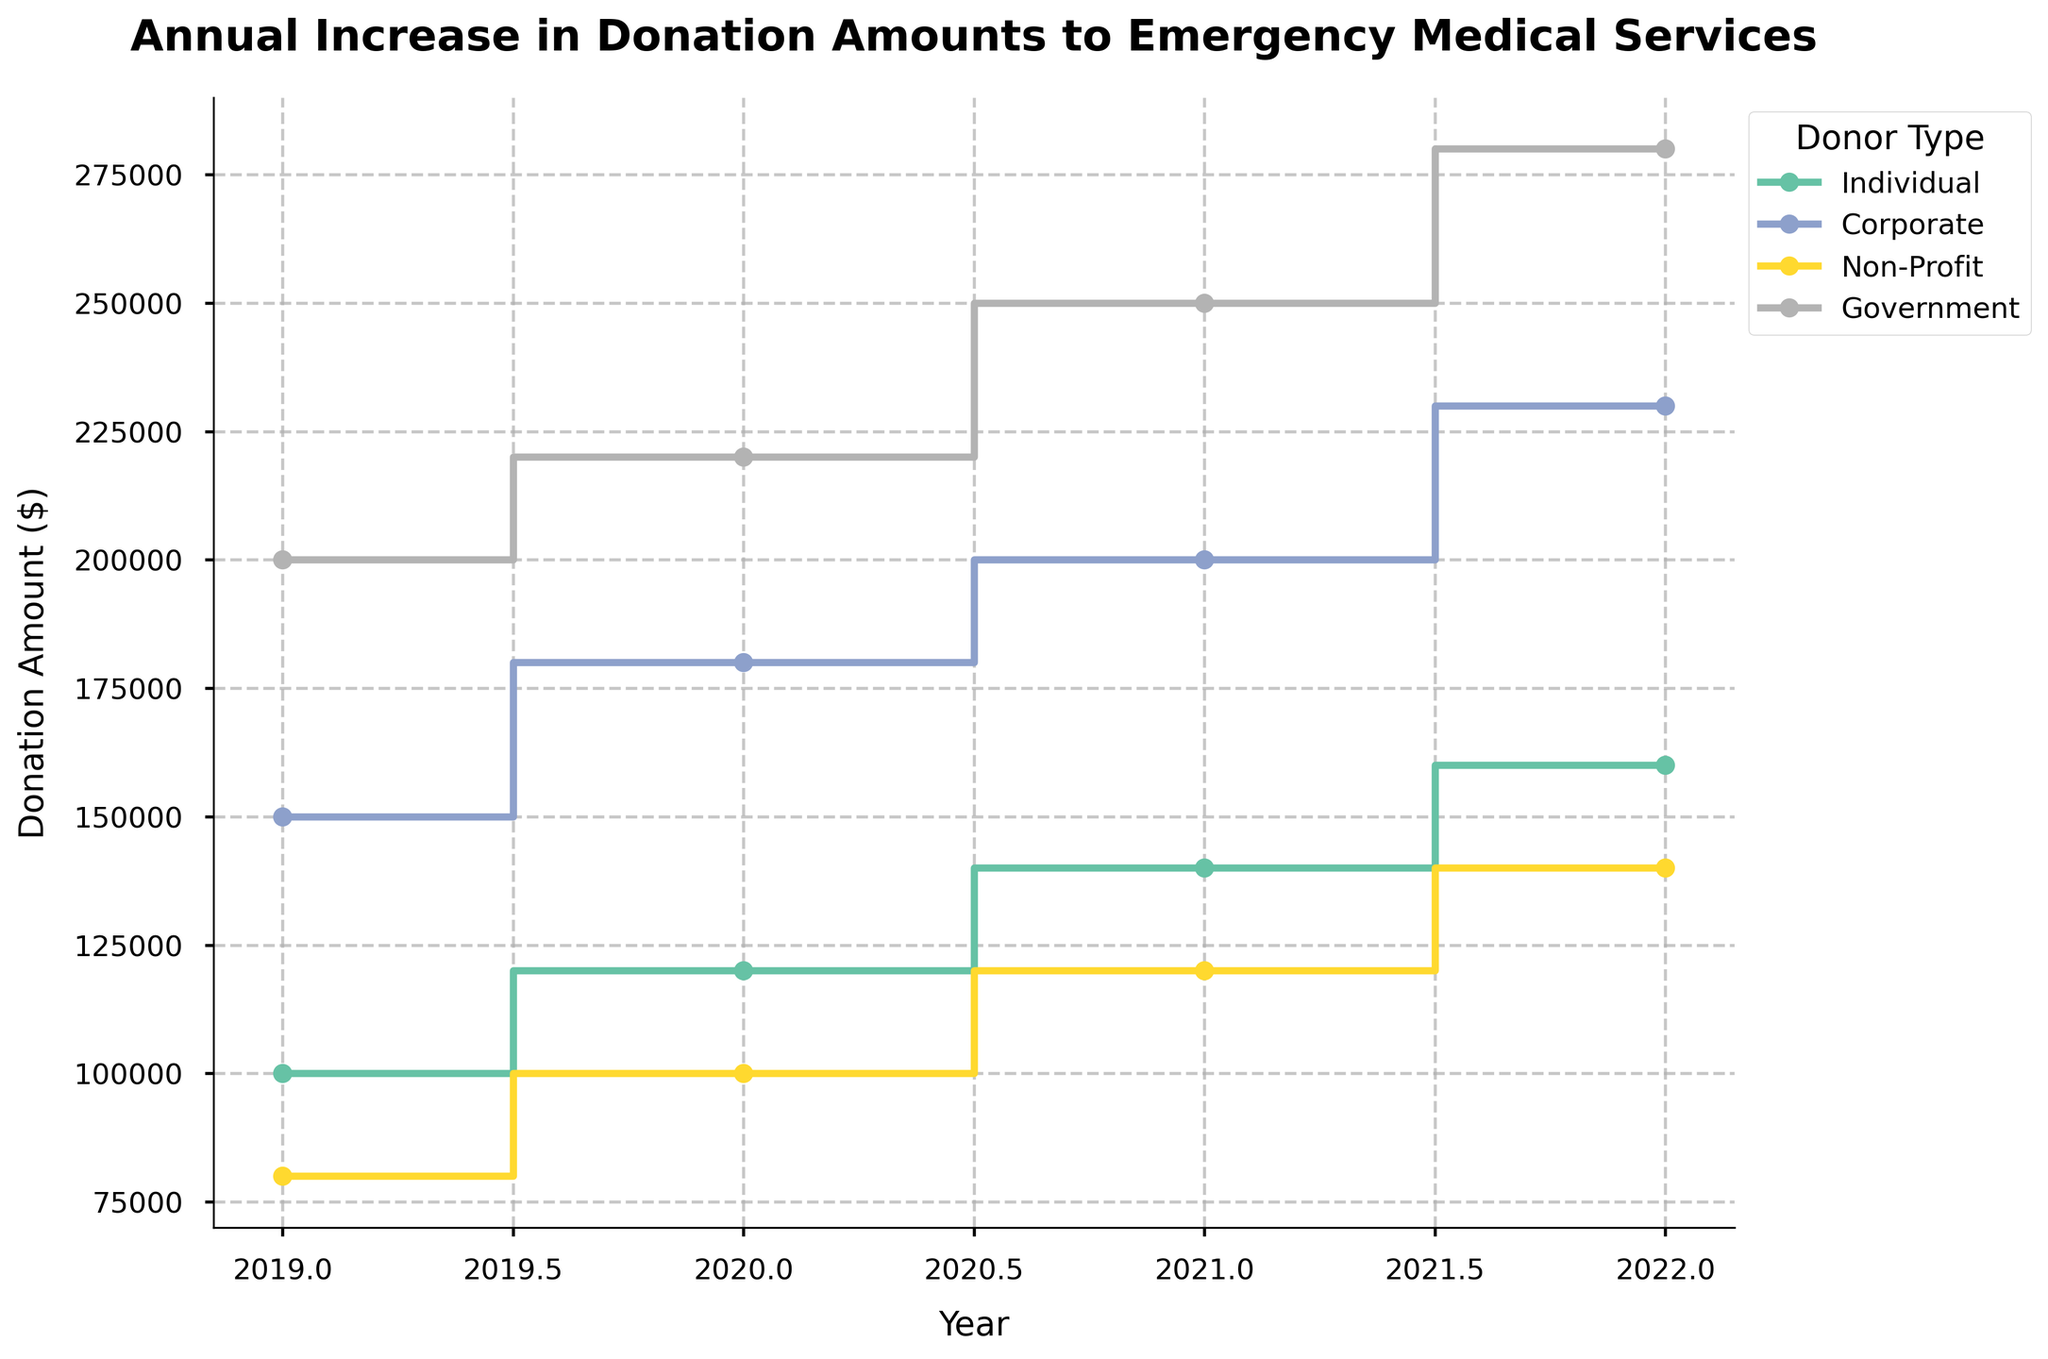What is the title of the plot? The title is displayed at the top center of the plot, it reads "Annual Increase in Donation Amounts to Emergency Medical Services".
Answer: Annual Increase in Donation Amounts to Emergency Medical Services What does the vertical axis represent? The label of the vertical axis indicates it represents the "Donation Amount ($)".
Answer: Donation Amount ($) How do the donations from Individuals change from 2019 to 2022? By observing the steps in the Individuals' series, we see the donation amounts increase each year: from $100,000 in 2019 to $120,000 in 2020, then to $140,000 in 2021, and $160,000 in 2022.
Answer: They increase every year Which donor type contributed the most in 2022? By comparing the positions of the steps for 2022, we see the highest donation amount is from the Government, reaching $280,000.
Answer: Government What is the average donation amount from Corporate donors between 2019 and 2022? First, add the yearly donations: $150,000 (2019) + $180,000 (2020) + $200,000 (2021) + $230,000 (2022) = $760,000. Then divide by the number of years (4): $760,000 / 4 = $190,000.
Answer: $190,000 Which donor type had the smallest increase in donations from 2019 to 2022? By comparing the donation amounts over the years for each donor type, Non-Profit shows an increase from $80,000 in 2019 to $140,000 in 2022, an increase of $60,000, which is the smallest among all donor types.
Answer: Non-Profit How much more did the Government donate in 2022 compared to 2019? The Government's donation amount was $200,000 in 2019 and $280,000 in 2022. The difference is $280,000 - $200,000 = $80,000.
Answer: $80,000 Which donor type shows the most significant increase in their donation amount between 2021 and 2022? By looking at the step changes between 2021 and 2022 for each donor type, the Government's donation increases from $250,000 to $280,000, a rise of $30,000, which is the largest increment.
Answer: Government What is the total donation amount from all donor types in 2020? Summing the donation amounts for 2020: Individual ($120,000) + Corporate ($180,000) + Non-Profit ($100,000) + Government ($220,000) = $620,000.
Answer: $620,000 